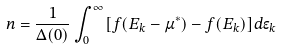Convert formula to latex. <formula><loc_0><loc_0><loc_500><loc_500>n = \frac { 1 } { \Delta ( 0 ) } \int ^ { \infty } _ { 0 } [ f ( E _ { k } - \mu ^ { * } ) - f ( E _ { k } ) ] d \epsilon _ { k }</formula> 